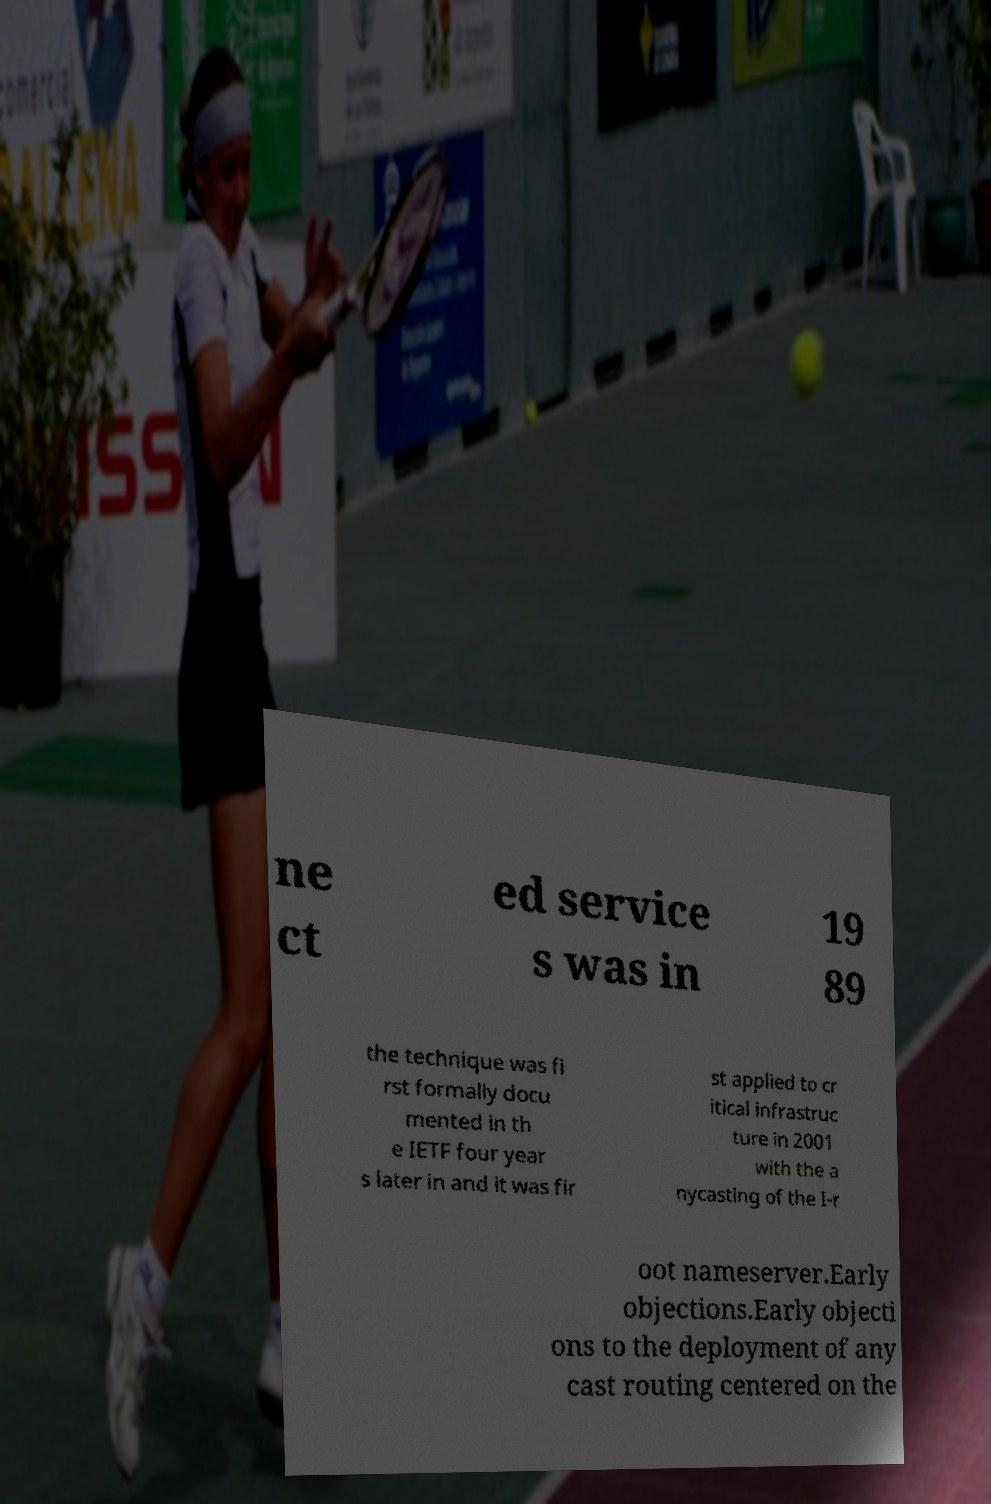Please read and relay the text visible in this image. What does it say? ne ct ed service s was in 19 89 the technique was fi rst formally docu mented in th e IETF four year s later in and it was fir st applied to cr itical infrastruc ture in 2001 with the a nycasting of the I-r oot nameserver.Early objections.Early objecti ons to the deployment of any cast routing centered on the 